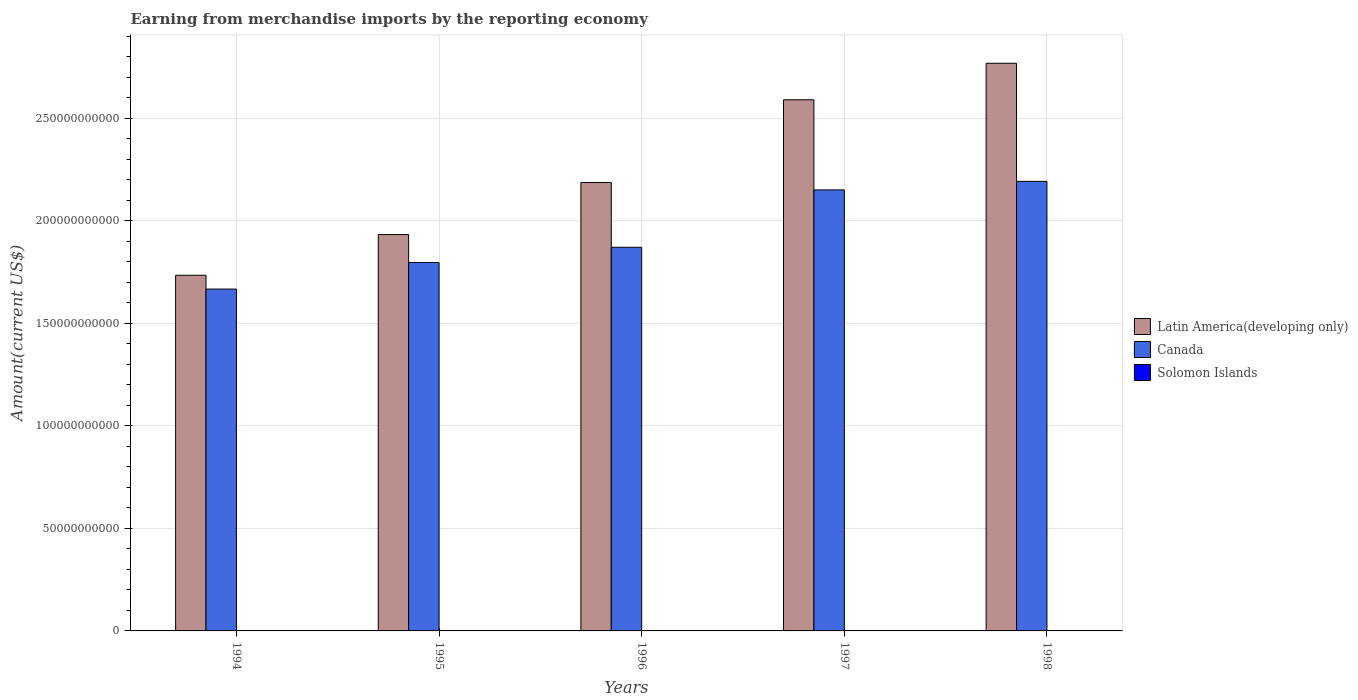How many different coloured bars are there?
Your answer should be very brief. 3. How many bars are there on the 4th tick from the right?
Your answer should be compact. 3. What is the label of the 5th group of bars from the left?
Keep it short and to the point. 1998. What is the amount earned from merchandise imports in Canada in 1996?
Keep it short and to the point. 1.87e+11. Across all years, what is the maximum amount earned from merchandise imports in Solomon Islands?
Your answer should be very brief. 1.80e+08. Across all years, what is the minimum amount earned from merchandise imports in Latin America(developing only)?
Offer a very short reply. 1.73e+11. In which year was the amount earned from merchandise imports in Solomon Islands maximum?
Your response must be concise. 1997. In which year was the amount earned from merchandise imports in Canada minimum?
Your answer should be compact. 1994. What is the total amount earned from merchandise imports in Latin America(developing only) in the graph?
Your response must be concise. 1.12e+12. What is the difference between the amount earned from merchandise imports in Latin America(developing only) in 1994 and that in 1998?
Ensure brevity in your answer.  -1.03e+11. What is the difference between the amount earned from merchandise imports in Latin America(developing only) in 1998 and the amount earned from merchandise imports in Solomon Islands in 1996?
Provide a succinct answer. 2.77e+11. What is the average amount earned from merchandise imports in Solomon Islands per year?
Keep it short and to the point. 1.58e+08. In the year 1998, what is the difference between the amount earned from merchandise imports in Latin America(developing only) and amount earned from merchandise imports in Canada?
Provide a short and direct response. 5.76e+1. What is the ratio of the amount earned from merchandise imports in Solomon Islands in 1995 to that in 1997?
Your answer should be very brief. 0.86. Is the amount earned from merchandise imports in Latin America(developing only) in 1997 less than that in 1998?
Offer a very short reply. Yes. What is the difference between the highest and the second highest amount earned from merchandise imports in Solomon Islands?
Provide a succinct answer. 1.31e+07. What is the difference between the highest and the lowest amount earned from merchandise imports in Solomon Islands?
Keep it short and to the point. 4.62e+07. In how many years, is the amount earned from merchandise imports in Latin America(developing only) greater than the average amount earned from merchandise imports in Latin America(developing only) taken over all years?
Provide a short and direct response. 2. Is the sum of the amount earned from merchandise imports in Latin America(developing only) in 1996 and 1998 greater than the maximum amount earned from merchandise imports in Canada across all years?
Your answer should be very brief. Yes. What does the 3rd bar from the left in 1997 represents?
Ensure brevity in your answer.  Solomon Islands. Is it the case that in every year, the sum of the amount earned from merchandise imports in Latin America(developing only) and amount earned from merchandise imports in Canada is greater than the amount earned from merchandise imports in Solomon Islands?
Offer a very short reply. Yes. What is the difference between two consecutive major ticks on the Y-axis?
Ensure brevity in your answer.  5.00e+1. Where does the legend appear in the graph?
Provide a succinct answer. Center right. How many legend labels are there?
Make the answer very short. 3. What is the title of the graph?
Ensure brevity in your answer.  Earning from merchandise imports by the reporting economy. Does "China" appear as one of the legend labels in the graph?
Offer a terse response. No. What is the label or title of the Y-axis?
Provide a succinct answer. Amount(current US$). What is the Amount(current US$) in Latin America(developing only) in 1994?
Offer a very short reply. 1.73e+11. What is the Amount(current US$) in Canada in 1994?
Your response must be concise. 1.67e+11. What is the Amount(current US$) in Solomon Islands in 1994?
Your answer should be very brief. 1.34e+08. What is the Amount(current US$) of Latin America(developing only) in 1995?
Your response must be concise. 1.93e+11. What is the Amount(current US$) of Canada in 1995?
Your response must be concise. 1.80e+11. What is the Amount(current US$) of Solomon Islands in 1995?
Your answer should be very brief. 1.55e+08. What is the Amount(current US$) in Latin America(developing only) in 1996?
Offer a very short reply. 2.19e+11. What is the Amount(current US$) of Canada in 1996?
Ensure brevity in your answer.  1.87e+11. What is the Amount(current US$) in Solomon Islands in 1996?
Provide a short and direct response. 1.67e+08. What is the Amount(current US$) in Latin America(developing only) in 1997?
Ensure brevity in your answer.  2.59e+11. What is the Amount(current US$) in Canada in 1997?
Ensure brevity in your answer.  2.15e+11. What is the Amount(current US$) of Solomon Islands in 1997?
Your response must be concise. 1.80e+08. What is the Amount(current US$) in Latin America(developing only) in 1998?
Provide a short and direct response. 2.77e+11. What is the Amount(current US$) of Canada in 1998?
Your answer should be very brief. 2.19e+11. What is the Amount(current US$) in Solomon Islands in 1998?
Give a very brief answer. 1.53e+08. Across all years, what is the maximum Amount(current US$) of Latin America(developing only)?
Your answer should be compact. 2.77e+11. Across all years, what is the maximum Amount(current US$) in Canada?
Give a very brief answer. 2.19e+11. Across all years, what is the maximum Amount(current US$) of Solomon Islands?
Your response must be concise. 1.80e+08. Across all years, what is the minimum Amount(current US$) in Latin America(developing only)?
Give a very brief answer. 1.73e+11. Across all years, what is the minimum Amount(current US$) of Canada?
Offer a very short reply. 1.67e+11. Across all years, what is the minimum Amount(current US$) of Solomon Islands?
Your response must be concise. 1.34e+08. What is the total Amount(current US$) of Latin America(developing only) in the graph?
Your response must be concise. 1.12e+12. What is the total Amount(current US$) in Canada in the graph?
Offer a terse response. 9.68e+11. What is the total Amount(current US$) in Solomon Islands in the graph?
Your answer should be very brief. 7.89e+08. What is the difference between the Amount(current US$) in Latin America(developing only) in 1994 and that in 1995?
Your answer should be very brief. -1.98e+1. What is the difference between the Amount(current US$) in Canada in 1994 and that in 1995?
Your response must be concise. -1.30e+1. What is the difference between the Amount(current US$) of Solomon Islands in 1994 and that in 1995?
Your response must be concise. -2.17e+07. What is the difference between the Amount(current US$) in Latin America(developing only) in 1994 and that in 1996?
Keep it short and to the point. -4.52e+1. What is the difference between the Amount(current US$) in Canada in 1994 and that in 1996?
Ensure brevity in your answer.  -2.04e+1. What is the difference between the Amount(current US$) of Solomon Islands in 1994 and that in 1996?
Offer a terse response. -3.31e+07. What is the difference between the Amount(current US$) of Latin America(developing only) in 1994 and that in 1997?
Make the answer very short. -8.55e+1. What is the difference between the Amount(current US$) of Canada in 1994 and that in 1997?
Offer a very short reply. -4.84e+1. What is the difference between the Amount(current US$) in Solomon Islands in 1994 and that in 1997?
Your answer should be very brief. -4.62e+07. What is the difference between the Amount(current US$) in Latin America(developing only) in 1994 and that in 1998?
Make the answer very short. -1.03e+11. What is the difference between the Amount(current US$) of Canada in 1994 and that in 1998?
Keep it short and to the point. -5.25e+1. What is the difference between the Amount(current US$) of Solomon Islands in 1994 and that in 1998?
Provide a short and direct response. -1.95e+07. What is the difference between the Amount(current US$) in Latin America(developing only) in 1995 and that in 1996?
Give a very brief answer. -2.54e+1. What is the difference between the Amount(current US$) in Canada in 1995 and that in 1996?
Keep it short and to the point. -7.43e+09. What is the difference between the Amount(current US$) of Solomon Islands in 1995 and that in 1996?
Keep it short and to the point. -1.15e+07. What is the difference between the Amount(current US$) in Latin America(developing only) in 1995 and that in 1997?
Make the answer very short. -6.57e+1. What is the difference between the Amount(current US$) in Canada in 1995 and that in 1997?
Your answer should be compact. -3.54e+1. What is the difference between the Amount(current US$) of Solomon Islands in 1995 and that in 1997?
Offer a very short reply. -2.45e+07. What is the difference between the Amount(current US$) in Latin America(developing only) in 1995 and that in 1998?
Keep it short and to the point. -8.35e+1. What is the difference between the Amount(current US$) of Canada in 1995 and that in 1998?
Your answer should be compact. -3.96e+1. What is the difference between the Amount(current US$) in Solomon Islands in 1995 and that in 1998?
Your answer should be compact. 2.13e+06. What is the difference between the Amount(current US$) in Latin America(developing only) in 1996 and that in 1997?
Your response must be concise. -4.03e+1. What is the difference between the Amount(current US$) of Canada in 1996 and that in 1997?
Provide a short and direct response. -2.80e+1. What is the difference between the Amount(current US$) of Solomon Islands in 1996 and that in 1997?
Offer a very short reply. -1.31e+07. What is the difference between the Amount(current US$) of Latin America(developing only) in 1996 and that in 1998?
Offer a terse response. -5.81e+1. What is the difference between the Amount(current US$) in Canada in 1996 and that in 1998?
Your answer should be very brief. -3.21e+1. What is the difference between the Amount(current US$) in Solomon Islands in 1996 and that in 1998?
Your answer should be very brief. 1.36e+07. What is the difference between the Amount(current US$) in Latin America(developing only) in 1997 and that in 1998?
Provide a short and direct response. -1.78e+1. What is the difference between the Amount(current US$) in Canada in 1997 and that in 1998?
Your answer should be very brief. -4.16e+09. What is the difference between the Amount(current US$) in Solomon Islands in 1997 and that in 1998?
Make the answer very short. 2.67e+07. What is the difference between the Amount(current US$) of Latin America(developing only) in 1994 and the Amount(current US$) of Canada in 1995?
Keep it short and to the point. -6.21e+09. What is the difference between the Amount(current US$) of Latin America(developing only) in 1994 and the Amount(current US$) of Solomon Islands in 1995?
Your answer should be very brief. 1.73e+11. What is the difference between the Amount(current US$) of Canada in 1994 and the Amount(current US$) of Solomon Islands in 1995?
Offer a terse response. 1.67e+11. What is the difference between the Amount(current US$) of Latin America(developing only) in 1994 and the Amount(current US$) of Canada in 1996?
Provide a succinct answer. -1.36e+1. What is the difference between the Amount(current US$) of Latin America(developing only) in 1994 and the Amount(current US$) of Solomon Islands in 1996?
Keep it short and to the point. 1.73e+11. What is the difference between the Amount(current US$) in Canada in 1994 and the Amount(current US$) in Solomon Islands in 1996?
Ensure brevity in your answer.  1.67e+11. What is the difference between the Amount(current US$) of Latin America(developing only) in 1994 and the Amount(current US$) of Canada in 1997?
Your answer should be compact. -4.16e+1. What is the difference between the Amount(current US$) in Latin America(developing only) in 1994 and the Amount(current US$) in Solomon Islands in 1997?
Your answer should be compact. 1.73e+11. What is the difference between the Amount(current US$) of Canada in 1994 and the Amount(current US$) of Solomon Islands in 1997?
Provide a short and direct response. 1.66e+11. What is the difference between the Amount(current US$) of Latin America(developing only) in 1994 and the Amount(current US$) of Canada in 1998?
Offer a terse response. -4.58e+1. What is the difference between the Amount(current US$) of Latin America(developing only) in 1994 and the Amount(current US$) of Solomon Islands in 1998?
Keep it short and to the point. 1.73e+11. What is the difference between the Amount(current US$) of Canada in 1994 and the Amount(current US$) of Solomon Islands in 1998?
Your response must be concise. 1.67e+11. What is the difference between the Amount(current US$) of Latin America(developing only) in 1995 and the Amount(current US$) of Canada in 1996?
Keep it short and to the point. 6.19e+09. What is the difference between the Amount(current US$) in Latin America(developing only) in 1995 and the Amount(current US$) in Solomon Islands in 1996?
Make the answer very short. 1.93e+11. What is the difference between the Amount(current US$) in Canada in 1995 and the Amount(current US$) in Solomon Islands in 1996?
Offer a very short reply. 1.79e+11. What is the difference between the Amount(current US$) in Latin America(developing only) in 1995 and the Amount(current US$) in Canada in 1997?
Make the answer very short. -2.18e+1. What is the difference between the Amount(current US$) of Latin America(developing only) in 1995 and the Amount(current US$) of Solomon Islands in 1997?
Ensure brevity in your answer.  1.93e+11. What is the difference between the Amount(current US$) of Canada in 1995 and the Amount(current US$) of Solomon Islands in 1997?
Keep it short and to the point. 1.79e+11. What is the difference between the Amount(current US$) in Latin America(developing only) in 1995 and the Amount(current US$) in Canada in 1998?
Your response must be concise. -2.59e+1. What is the difference between the Amount(current US$) in Latin America(developing only) in 1995 and the Amount(current US$) in Solomon Islands in 1998?
Ensure brevity in your answer.  1.93e+11. What is the difference between the Amount(current US$) in Canada in 1995 and the Amount(current US$) in Solomon Islands in 1998?
Keep it short and to the point. 1.79e+11. What is the difference between the Amount(current US$) in Latin America(developing only) in 1996 and the Amount(current US$) in Canada in 1997?
Give a very brief answer. 3.61e+09. What is the difference between the Amount(current US$) of Latin America(developing only) in 1996 and the Amount(current US$) of Solomon Islands in 1997?
Ensure brevity in your answer.  2.18e+11. What is the difference between the Amount(current US$) of Canada in 1996 and the Amount(current US$) of Solomon Islands in 1997?
Your answer should be very brief. 1.87e+11. What is the difference between the Amount(current US$) of Latin America(developing only) in 1996 and the Amount(current US$) of Canada in 1998?
Your response must be concise. -5.47e+08. What is the difference between the Amount(current US$) of Latin America(developing only) in 1996 and the Amount(current US$) of Solomon Islands in 1998?
Ensure brevity in your answer.  2.18e+11. What is the difference between the Amount(current US$) of Canada in 1996 and the Amount(current US$) of Solomon Islands in 1998?
Offer a terse response. 1.87e+11. What is the difference between the Amount(current US$) of Latin America(developing only) in 1997 and the Amount(current US$) of Canada in 1998?
Provide a succinct answer. 3.98e+1. What is the difference between the Amount(current US$) in Latin America(developing only) in 1997 and the Amount(current US$) in Solomon Islands in 1998?
Provide a short and direct response. 2.59e+11. What is the difference between the Amount(current US$) of Canada in 1997 and the Amount(current US$) of Solomon Islands in 1998?
Provide a succinct answer. 2.15e+11. What is the average Amount(current US$) in Latin America(developing only) per year?
Provide a short and direct response. 2.24e+11. What is the average Amount(current US$) in Canada per year?
Your response must be concise. 1.94e+11. What is the average Amount(current US$) of Solomon Islands per year?
Your answer should be compact. 1.58e+08. In the year 1994, what is the difference between the Amount(current US$) in Latin America(developing only) and Amount(current US$) in Canada?
Give a very brief answer. 6.74e+09. In the year 1994, what is the difference between the Amount(current US$) in Latin America(developing only) and Amount(current US$) in Solomon Islands?
Your answer should be compact. 1.73e+11. In the year 1994, what is the difference between the Amount(current US$) of Canada and Amount(current US$) of Solomon Islands?
Provide a short and direct response. 1.67e+11. In the year 1995, what is the difference between the Amount(current US$) of Latin America(developing only) and Amount(current US$) of Canada?
Offer a terse response. 1.36e+1. In the year 1995, what is the difference between the Amount(current US$) of Latin America(developing only) and Amount(current US$) of Solomon Islands?
Keep it short and to the point. 1.93e+11. In the year 1995, what is the difference between the Amount(current US$) of Canada and Amount(current US$) of Solomon Islands?
Offer a very short reply. 1.79e+11. In the year 1996, what is the difference between the Amount(current US$) of Latin America(developing only) and Amount(current US$) of Canada?
Offer a very short reply. 3.16e+1. In the year 1996, what is the difference between the Amount(current US$) of Latin America(developing only) and Amount(current US$) of Solomon Islands?
Make the answer very short. 2.18e+11. In the year 1996, what is the difference between the Amount(current US$) in Canada and Amount(current US$) in Solomon Islands?
Your response must be concise. 1.87e+11. In the year 1997, what is the difference between the Amount(current US$) in Latin America(developing only) and Amount(current US$) in Canada?
Your response must be concise. 4.39e+1. In the year 1997, what is the difference between the Amount(current US$) in Latin America(developing only) and Amount(current US$) in Solomon Islands?
Make the answer very short. 2.59e+11. In the year 1997, what is the difference between the Amount(current US$) in Canada and Amount(current US$) in Solomon Islands?
Provide a short and direct response. 2.15e+11. In the year 1998, what is the difference between the Amount(current US$) of Latin America(developing only) and Amount(current US$) of Canada?
Your response must be concise. 5.76e+1. In the year 1998, what is the difference between the Amount(current US$) in Latin America(developing only) and Amount(current US$) in Solomon Islands?
Provide a short and direct response. 2.77e+11. In the year 1998, what is the difference between the Amount(current US$) in Canada and Amount(current US$) in Solomon Islands?
Offer a terse response. 2.19e+11. What is the ratio of the Amount(current US$) in Latin America(developing only) in 1994 to that in 1995?
Offer a very short reply. 0.9. What is the ratio of the Amount(current US$) of Canada in 1994 to that in 1995?
Offer a very short reply. 0.93. What is the ratio of the Amount(current US$) in Solomon Islands in 1994 to that in 1995?
Provide a succinct answer. 0.86. What is the ratio of the Amount(current US$) in Latin America(developing only) in 1994 to that in 1996?
Ensure brevity in your answer.  0.79. What is the ratio of the Amount(current US$) of Canada in 1994 to that in 1996?
Ensure brevity in your answer.  0.89. What is the ratio of the Amount(current US$) in Solomon Islands in 1994 to that in 1996?
Your answer should be very brief. 0.8. What is the ratio of the Amount(current US$) of Latin America(developing only) in 1994 to that in 1997?
Your answer should be compact. 0.67. What is the ratio of the Amount(current US$) in Canada in 1994 to that in 1997?
Make the answer very short. 0.78. What is the ratio of the Amount(current US$) in Solomon Islands in 1994 to that in 1997?
Offer a very short reply. 0.74. What is the ratio of the Amount(current US$) of Latin America(developing only) in 1994 to that in 1998?
Your answer should be very brief. 0.63. What is the ratio of the Amount(current US$) in Canada in 1994 to that in 1998?
Ensure brevity in your answer.  0.76. What is the ratio of the Amount(current US$) of Solomon Islands in 1994 to that in 1998?
Your answer should be compact. 0.87. What is the ratio of the Amount(current US$) of Latin America(developing only) in 1995 to that in 1996?
Your answer should be very brief. 0.88. What is the ratio of the Amount(current US$) in Canada in 1995 to that in 1996?
Offer a very short reply. 0.96. What is the ratio of the Amount(current US$) of Solomon Islands in 1995 to that in 1996?
Ensure brevity in your answer.  0.93. What is the ratio of the Amount(current US$) in Latin America(developing only) in 1995 to that in 1997?
Give a very brief answer. 0.75. What is the ratio of the Amount(current US$) of Canada in 1995 to that in 1997?
Your answer should be very brief. 0.84. What is the ratio of the Amount(current US$) of Solomon Islands in 1995 to that in 1997?
Give a very brief answer. 0.86. What is the ratio of the Amount(current US$) in Latin America(developing only) in 1995 to that in 1998?
Your answer should be very brief. 0.7. What is the ratio of the Amount(current US$) in Canada in 1995 to that in 1998?
Your answer should be very brief. 0.82. What is the ratio of the Amount(current US$) in Solomon Islands in 1995 to that in 1998?
Offer a terse response. 1.01. What is the ratio of the Amount(current US$) of Latin America(developing only) in 1996 to that in 1997?
Your answer should be compact. 0.84. What is the ratio of the Amount(current US$) in Canada in 1996 to that in 1997?
Keep it short and to the point. 0.87. What is the ratio of the Amount(current US$) in Solomon Islands in 1996 to that in 1997?
Your answer should be very brief. 0.93. What is the ratio of the Amount(current US$) in Latin America(developing only) in 1996 to that in 1998?
Give a very brief answer. 0.79. What is the ratio of the Amount(current US$) of Canada in 1996 to that in 1998?
Offer a very short reply. 0.85. What is the ratio of the Amount(current US$) in Solomon Islands in 1996 to that in 1998?
Ensure brevity in your answer.  1.09. What is the ratio of the Amount(current US$) in Latin America(developing only) in 1997 to that in 1998?
Keep it short and to the point. 0.94. What is the ratio of the Amount(current US$) of Canada in 1997 to that in 1998?
Ensure brevity in your answer.  0.98. What is the ratio of the Amount(current US$) in Solomon Islands in 1997 to that in 1998?
Provide a short and direct response. 1.17. What is the difference between the highest and the second highest Amount(current US$) of Latin America(developing only)?
Your response must be concise. 1.78e+1. What is the difference between the highest and the second highest Amount(current US$) of Canada?
Ensure brevity in your answer.  4.16e+09. What is the difference between the highest and the second highest Amount(current US$) in Solomon Islands?
Offer a very short reply. 1.31e+07. What is the difference between the highest and the lowest Amount(current US$) of Latin America(developing only)?
Ensure brevity in your answer.  1.03e+11. What is the difference between the highest and the lowest Amount(current US$) of Canada?
Your response must be concise. 5.25e+1. What is the difference between the highest and the lowest Amount(current US$) in Solomon Islands?
Offer a very short reply. 4.62e+07. 